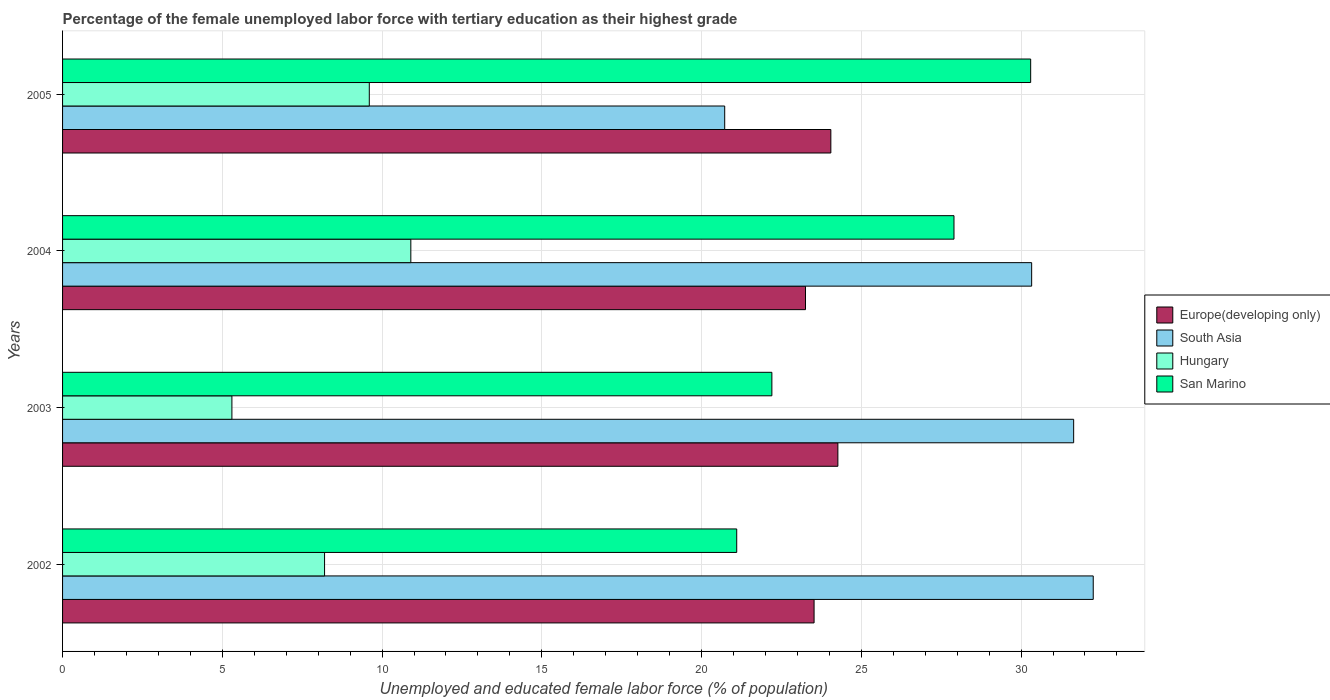How many groups of bars are there?
Offer a terse response. 4. How many bars are there on the 3rd tick from the top?
Provide a short and direct response. 4. What is the label of the 3rd group of bars from the top?
Offer a terse response. 2003. In how many cases, is the number of bars for a given year not equal to the number of legend labels?
Give a very brief answer. 0. What is the percentage of the unemployed female labor force with tertiary education in South Asia in 2005?
Provide a short and direct response. 20.72. Across all years, what is the maximum percentage of the unemployed female labor force with tertiary education in South Asia?
Make the answer very short. 32.26. Across all years, what is the minimum percentage of the unemployed female labor force with tertiary education in San Marino?
Provide a succinct answer. 21.1. In which year was the percentage of the unemployed female labor force with tertiary education in Hungary minimum?
Keep it short and to the point. 2003. What is the total percentage of the unemployed female labor force with tertiary education in Europe(developing only) in the graph?
Your response must be concise. 95.09. What is the difference between the percentage of the unemployed female labor force with tertiary education in San Marino in 2003 and that in 2005?
Provide a succinct answer. -8.1. What is the difference between the percentage of the unemployed female labor force with tertiary education in San Marino in 2005 and the percentage of the unemployed female labor force with tertiary education in Hungary in 2002?
Keep it short and to the point. 22.1. What is the average percentage of the unemployed female labor force with tertiary education in Europe(developing only) per year?
Your response must be concise. 23.77. In the year 2004, what is the difference between the percentage of the unemployed female labor force with tertiary education in San Marino and percentage of the unemployed female labor force with tertiary education in Hungary?
Ensure brevity in your answer.  17. What is the ratio of the percentage of the unemployed female labor force with tertiary education in Hungary in 2003 to that in 2004?
Make the answer very short. 0.49. What is the difference between the highest and the second highest percentage of the unemployed female labor force with tertiary education in South Asia?
Your answer should be compact. 0.61. What is the difference between the highest and the lowest percentage of the unemployed female labor force with tertiary education in South Asia?
Keep it short and to the point. 11.53. What does the 1st bar from the top in 2003 represents?
Provide a succinct answer. San Marino. What does the 3rd bar from the bottom in 2003 represents?
Keep it short and to the point. Hungary. Is it the case that in every year, the sum of the percentage of the unemployed female labor force with tertiary education in Europe(developing only) and percentage of the unemployed female labor force with tertiary education in San Marino is greater than the percentage of the unemployed female labor force with tertiary education in South Asia?
Give a very brief answer. Yes. What is the difference between two consecutive major ticks on the X-axis?
Provide a short and direct response. 5. Are the values on the major ticks of X-axis written in scientific E-notation?
Give a very brief answer. No. Does the graph contain any zero values?
Offer a very short reply. No. Does the graph contain grids?
Offer a terse response. Yes. Where does the legend appear in the graph?
Keep it short and to the point. Center right. What is the title of the graph?
Offer a terse response. Percentage of the female unemployed labor force with tertiary education as their highest grade. What is the label or title of the X-axis?
Your answer should be compact. Unemployed and educated female labor force (% of population). What is the label or title of the Y-axis?
Your answer should be compact. Years. What is the Unemployed and educated female labor force (% of population) in Europe(developing only) in 2002?
Make the answer very short. 23.52. What is the Unemployed and educated female labor force (% of population) of South Asia in 2002?
Offer a terse response. 32.26. What is the Unemployed and educated female labor force (% of population) in Hungary in 2002?
Your response must be concise. 8.2. What is the Unemployed and educated female labor force (% of population) in San Marino in 2002?
Ensure brevity in your answer.  21.1. What is the Unemployed and educated female labor force (% of population) in Europe(developing only) in 2003?
Offer a very short reply. 24.27. What is the Unemployed and educated female labor force (% of population) in South Asia in 2003?
Provide a short and direct response. 31.65. What is the Unemployed and educated female labor force (% of population) in Hungary in 2003?
Provide a succinct answer. 5.3. What is the Unemployed and educated female labor force (% of population) of San Marino in 2003?
Keep it short and to the point. 22.2. What is the Unemployed and educated female labor force (% of population) in Europe(developing only) in 2004?
Your answer should be very brief. 23.25. What is the Unemployed and educated female labor force (% of population) in South Asia in 2004?
Give a very brief answer. 30.33. What is the Unemployed and educated female labor force (% of population) of Hungary in 2004?
Make the answer very short. 10.9. What is the Unemployed and educated female labor force (% of population) in San Marino in 2004?
Make the answer very short. 27.9. What is the Unemployed and educated female labor force (% of population) in Europe(developing only) in 2005?
Keep it short and to the point. 24.05. What is the Unemployed and educated female labor force (% of population) of South Asia in 2005?
Give a very brief answer. 20.72. What is the Unemployed and educated female labor force (% of population) of Hungary in 2005?
Your response must be concise. 9.6. What is the Unemployed and educated female labor force (% of population) in San Marino in 2005?
Provide a short and direct response. 30.3. Across all years, what is the maximum Unemployed and educated female labor force (% of population) of Europe(developing only)?
Your response must be concise. 24.27. Across all years, what is the maximum Unemployed and educated female labor force (% of population) in South Asia?
Provide a succinct answer. 32.26. Across all years, what is the maximum Unemployed and educated female labor force (% of population) of Hungary?
Your response must be concise. 10.9. Across all years, what is the maximum Unemployed and educated female labor force (% of population) in San Marino?
Keep it short and to the point. 30.3. Across all years, what is the minimum Unemployed and educated female labor force (% of population) in Europe(developing only)?
Keep it short and to the point. 23.25. Across all years, what is the minimum Unemployed and educated female labor force (% of population) of South Asia?
Your answer should be very brief. 20.72. Across all years, what is the minimum Unemployed and educated female labor force (% of population) in Hungary?
Offer a terse response. 5.3. Across all years, what is the minimum Unemployed and educated female labor force (% of population) of San Marino?
Provide a succinct answer. 21.1. What is the total Unemployed and educated female labor force (% of population) of Europe(developing only) in the graph?
Keep it short and to the point. 95.09. What is the total Unemployed and educated female labor force (% of population) of South Asia in the graph?
Give a very brief answer. 114.96. What is the total Unemployed and educated female labor force (% of population) of San Marino in the graph?
Your response must be concise. 101.5. What is the difference between the Unemployed and educated female labor force (% of population) of Europe(developing only) in 2002 and that in 2003?
Offer a very short reply. -0.74. What is the difference between the Unemployed and educated female labor force (% of population) of South Asia in 2002 and that in 2003?
Ensure brevity in your answer.  0.61. What is the difference between the Unemployed and educated female labor force (% of population) of San Marino in 2002 and that in 2003?
Offer a very short reply. -1.1. What is the difference between the Unemployed and educated female labor force (% of population) of Europe(developing only) in 2002 and that in 2004?
Your answer should be compact. 0.27. What is the difference between the Unemployed and educated female labor force (% of population) of South Asia in 2002 and that in 2004?
Offer a terse response. 1.93. What is the difference between the Unemployed and educated female labor force (% of population) in Hungary in 2002 and that in 2004?
Keep it short and to the point. -2.7. What is the difference between the Unemployed and educated female labor force (% of population) in Europe(developing only) in 2002 and that in 2005?
Provide a succinct answer. -0.52. What is the difference between the Unemployed and educated female labor force (% of population) of South Asia in 2002 and that in 2005?
Offer a very short reply. 11.53. What is the difference between the Unemployed and educated female labor force (% of population) in Hungary in 2002 and that in 2005?
Offer a terse response. -1.4. What is the difference between the Unemployed and educated female labor force (% of population) of San Marino in 2002 and that in 2005?
Ensure brevity in your answer.  -9.2. What is the difference between the Unemployed and educated female labor force (% of population) in Europe(developing only) in 2003 and that in 2004?
Make the answer very short. 1.01. What is the difference between the Unemployed and educated female labor force (% of population) in South Asia in 2003 and that in 2004?
Your answer should be very brief. 1.31. What is the difference between the Unemployed and educated female labor force (% of population) of Europe(developing only) in 2003 and that in 2005?
Give a very brief answer. 0.22. What is the difference between the Unemployed and educated female labor force (% of population) in South Asia in 2003 and that in 2005?
Your answer should be very brief. 10.92. What is the difference between the Unemployed and educated female labor force (% of population) in Europe(developing only) in 2004 and that in 2005?
Give a very brief answer. -0.79. What is the difference between the Unemployed and educated female labor force (% of population) of South Asia in 2004 and that in 2005?
Make the answer very short. 9.61. What is the difference between the Unemployed and educated female labor force (% of population) of Hungary in 2004 and that in 2005?
Your answer should be very brief. 1.3. What is the difference between the Unemployed and educated female labor force (% of population) of Europe(developing only) in 2002 and the Unemployed and educated female labor force (% of population) of South Asia in 2003?
Ensure brevity in your answer.  -8.12. What is the difference between the Unemployed and educated female labor force (% of population) of Europe(developing only) in 2002 and the Unemployed and educated female labor force (% of population) of Hungary in 2003?
Keep it short and to the point. 18.22. What is the difference between the Unemployed and educated female labor force (% of population) in Europe(developing only) in 2002 and the Unemployed and educated female labor force (% of population) in San Marino in 2003?
Keep it short and to the point. 1.32. What is the difference between the Unemployed and educated female labor force (% of population) in South Asia in 2002 and the Unemployed and educated female labor force (% of population) in Hungary in 2003?
Offer a terse response. 26.96. What is the difference between the Unemployed and educated female labor force (% of population) of South Asia in 2002 and the Unemployed and educated female labor force (% of population) of San Marino in 2003?
Ensure brevity in your answer.  10.06. What is the difference between the Unemployed and educated female labor force (% of population) of Hungary in 2002 and the Unemployed and educated female labor force (% of population) of San Marino in 2003?
Provide a succinct answer. -14. What is the difference between the Unemployed and educated female labor force (% of population) in Europe(developing only) in 2002 and the Unemployed and educated female labor force (% of population) in South Asia in 2004?
Give a very brief answer. -6.81. What is the difference between the Unemployed and educated female labor force (% of population) in Europe(developing only) in 2002 and the Unemployed and educated female labor force (% of population) in Hungary in 2004?
Your answer should be compact. 12.62. What is the difference between the Unemployed and educated female labor force (% of population) of Europe(developing only) in 2002 and the Unemployed and educated female labor force (% of population) of San Marino in 2004?
Your answer should be compact. -4.38. What is the difference between the Unemployed and educated female labor force (% of population) of South Asia in 2002 and the Unemployed and educated female labor force (% of population) of Hungary in 2004?
Provide a succinct answer. 21.36. What is the difference between the Unemployed and educated female labor force (% of population) of South Asia in 2002 and the Unemployed and educated female labor force (% of population) of San Marino in 2004?
Your answer should be very brief. 4.36. What is the difference between the Unemployed and educated female labor force (% of population) of Hungary in 2002 and the Unemployed and educated female labor force (% of population) of San Marino in 2004?
Provide a succinct answer. -19.7. What is the difference between the Unemployed and educated female labor force (% of population) in Europe(developing only) in 2002 and the Unemployed and educated female labor force (% of population) in South Asia in 2005?
Your response must be concise. 2.8. What is the difference between the Unemployed and educated female labor force (% of population) of Europe(developing only) in 2002 and the Unemployed and educated female labor force (% of population) of Hungary in 2005?
Make the answer very short. 13.92. What is the difference between the Unemployed and educated female labor force (% of population) in Europe(developing only) in 2002 and the Unemployed and educated female labor force (% of population) in San Marino in 2005?
Offer a very short reply. -6.78. What is the difference between the Unemployed and educated female labor force (% of population) in South Asia in 2002 and the Unemployed and educated female labor force (% of population) in Hungary in 2005?
Offer a very short reply. 22.66. What is the difference between the Unemployed and educated female labor force (% of population) in South Asia in 2002 and the Unemployed and educated female labor force (% of population) in San Marino in 2005?
Provide a short and direct response. 1.96. What is the difference between the Unemployed and educated female labor force (% of population) of Hungary in 2002 and the Unemployed and educated female labor force (% of population) of San Marino in 2005?
Offer a terse response. -22.1. What is the difference between the Unemployed and educated female labor force (% of population) of Europe(developing only) in 2003 and the Unemployed and educated female labor force (% of population) of South Asia in 2004?
Your answer should be very brief. -6.06. What is the difference between the Unemployed and educated female labor force (% of population) in Europe(developing only) in 2003 and the Unemployed and educated female labor force (% of population) in Hungary in 2004?
Keep it short and to the point. 13.37. What is the difference between the Unemployed and educated female labor force (% of population) of Europe(developing only) in 2003 and the Unemployed and educated female labor force (% of population) of San Marino in 2004?
Your answer should be very brief. -3.63. What is the difference between the Unemployed and educated female labor force (% of population) in South Asia in 2003 and the Unemployed and educated female labor force (% of population) in Hungary in 2004?
Ensure brevity in your answer.  20.75. What is the difference between the Unemployed and educated female labor force (% of population) of South Asia in 2003 and the Unemployed and educated female labor force (% of population) of San Marino in 2004?
Ensure brevity in your answer.  3.75. What is the difference between the Unemployed and educated female labor force (% of population) in Hungary in 2003 and the Unemployed and educated female labor force (% of population) in San Marino in 2004?
Provide a succinct answer. -22.6. What is the difference between the Unemployed and educated female labor force (% of population) of Europe(developing only) in 2003 and the Unemployed and educated female labor force (% of population) of South Asia in 2005?
Ensure brevity in your answer.  3.54. What is the difference between the Unemployed and educated female labor force (% of population) of Europe(developing only) in 2003 and the Unemployed and educated female labor force (% of population) of Hungary in 2005?
Ensure brevity in your answer.  14.67. What is the difference between the Unemployed and educated female labor force (% of population) of Europe(developing only) in 2003 and the Unemployed and educated female labor force (% of population) of San Marino in 2005?
Offer a very short reply. -6.03. What is the difference between the Unemployed and educated female labor force (% of population) of South Asia in 2003 and the Unemployed and educated female labor force (% of population) of Hungary in 2005?
Offer a very short reply. 22.05. What is the difference between the Unemployed and educated female labor force (% of population) of South Asia in 2003 and the Unemployed and educated female labor force (% of population) of San Marino in 2005?
Ensure brevity in your answer.  1.35. What is the difference between the Unemployed and educated female labor force (% of population) of Hungary in 2003 and the Unemployed and educated female labor force (% of population) of San Marino in 2005?
Your answer should be very brief. -25. What is the difference between the Unemployed and educated female labor force (% of population) of Europe(developing only) in 2004 and the Unemployed and educated female labor force (% of population) of South Asia in 2005?
Your answer should be compact. 2.53. What is the difference between the Unemployed and educated female labor force (% of population) in Europe(developing only) in 2004 and the Unemployed and educated female labor force (% of population) in Hungary in 2005?
Ensure brevity in your answer.  13.65. What is the difference between the Unemployed and educated female labor force (% of population) of Europe(developing only) in 2004 and the Unemployed and educated female labor force (% of population) of San Marino in 2005?
Ensure brevity in your answer.  -7.05. What is the difference between the Unemployed and educated female labor force (% of population) of South Asia in 2004 and the Unemployed and educated female labor force (% of population) of Hungary in 2005?
Keep it short and to the point. 20.73. What is the difference between the Unemployed and educated female labor force (% of population) in South Asia in 2004 and the Unemployed and educated female labor force (% of population) in San Marino in 2005?
Your response must be concise. 0.03. What is the difference between the Unemployed and educated female labor force (% of population) of Hungary in 2004 and the Unemployed and educated female labor force (% of population) of San Marino in 2005?
Keep it short and to the point. -19.4. What is the average Unemployed and educated female labor force (% of population) of Europe(developing only) per year?
Ensure brevity in your answer.  23.77. What is the average Unemployed and educated female labor force (% of population) of South Asia per year?
Ensure brevity in your answer.  28.74. What is the average Unemployed and educated female labor force (% of population) in Hungary per year?
Offer a terse response. 8.5. What is the average Unemployed and educated female labor force (% of population) in San Marino per year?
Provide a succinct answer. 25.38. In the year 2002, what is the difference between the Unemployed and educated female labor force (% of population) of Europe(developing only) and Unemployed and educated female labor force (% of population) of South Asia?
Your response must be concise. -8.74. In the year 2002, what is the difference between the Unemployed and educated female labor force (% of population) of Europe(developing only) and Unemployed and educated female labor force (% of population) of Hungary?
Your answer should be compact. 15.32. In the year 2002, what is the difference between the Unemployed and educated female labor force (% of population) in Europe(developing only) and Unemployed and educated female labor force (% of population) in San Marino?
Your answer should be compact. 2.42. In the year 2002, what is the difference between the Unemployed and educated female labor force (% of population) in South Asia and Unemployed and educated female labor force (% of population) in Hungary?
Your answer should be compact. 24.06. In the year 2002, what is the difference between the Unemployed and educated female labor force (% of population) in South Asia and Unemployed and educated female labor force (% of population) in San Marino?
Provide a short and direct response. 11.16. In the year 2003, what is the difference between the Unemployed and educated female labor force (% of population) in Europe(developing only) and Unemployed and educated female labor force (% of population) in South Asia?
Make the answer very short. -7.38. In the year 2003, what is the difference between the Unemployed and educated female labor force (% of population) in Europe(developing only) and Unemployed and educated female labor force (% of population) in Hungary?
Keep it short and to the point. 18.97. In the year 2003, what is the difference between the Unemployed and educated female labor force (% of population) of Europe(developing only) and Unemployed and educated female labor force (% of population) of San Marino?
Give a very brief answer. 2.07. In the year 2003, what is the difference between the Unemployed and educated female labor force (% of population) in South Asia and Unemployed and educated female labor force (% of population) in Hungary?
Offer a terse response. 26.35. In the year 2003, what is the difference between the Unemployed and educated female labor force (% of population) of South Asia and Unemployed and educated female labor force (% of population) of San Marino?
Your answer should be compact. 9.45. In the year 2003, what is the difference between the Unemployed and educated female labor force (% of population) in Hungary and Unemployed and educated female labor force (% of population) in San Marino?
Keep it short and to the point. -16.9. In the year 2004, what is the difference between the Unemployed and educated female labor force (% of population) of Europe(developing only) and Unemployed and educated female labor force (% of population) of South Asia?
Your answer should be compact. -7.08. In the year 2004, what is the difference between the Unemployed and educated female labor force (% of population) in Europe(developing only) and Unemployed and educated female labor force (% of population) in Hungary?
Give a very brief answer. 12.35. In the year 2004, what is the difference between the Unemployed and educated female labor force (% of population) in Europe(developing only) and Unemployed and educated female labor force (% of population) in San Marino?
Your answer should be very brief. -4.65. In the year 2004, what is the difference between the Unemployed and educated female labor force (% of population) of South Asia and Unemployed and educated female labor force (% of population) of Hungary?
Offer a terse response. 19.43. In the year 2004, what is the difference between the Unemployed and educated female labor force (% of population) of South Asia and Unemployed and educated female labor force (% of population) of San Marino?
Ensure brevity in your answer.  2.43. In the year 2004, what is the difference between the Unemployed and educated female labor force (% of population) in Hungary and Unemployed and educated female labor force (% of population) in San Marino?
Keep it short and to the point. -17. In the year 2005, what is the difference between the Unemployed and educated female labor force (% of population) in Europe(developing only) and Unemployed and educated female labor force (% of population) in South Asia?
Ensure brevity in your answer.  3.32. In the year 2005, what is the difference between the Unemployed and educated female labor force (% of population) of Europe(developing only) and Unemployed and educated female labor force (% of population) of Hungary?
Your response must be concise. 14.45. In the year 2005, what is the difference between the Unemployed and educated female labor force (% of population) of Europe(developing only) and Unemployed and educated female labor force (% of population) of San Marino?
Give a very brief answer. -6.25. In the year 2005, what is the difference between the Unemployed and educated female labor force (% of population) of South Asia and Unemployed and educated female labor force (% of population) of Hungary?
Offer a very short reply. 11.12. In the year 2005, what is the difference between the Unemployed and educated female labor force (% of population) in South Asia and Unemployed and educated female labor force (% of population) in San Marino?
Your answer should be compact. -9.58. In the year 2005, what is the difference between the Unemployed and educated female labor force (% of population) in Hungary and Unemployed and educated female labor force (% of population) in San Marino?
Offer a very short reply. -20.7. What is the ratio of the Unemployed and educated female labor force (% of population) of Europe(developing only) in 2002 to that in 2003?
Your answer should be compact. 0.97. What is the ratio of the Unemployed and educated female labor force (% of population) of South Asia in 2002 to that in 2003?
Make the answer very short. 1.02. What is the ratio of the Unemployed and educated female labor force (% of population) in Hungary in 2002 to that in 2003?
Keep it short and to the point. 1.55. What is the ratio of the Unemployed and educated female labor force (% of population) of San Marino in 2002 to that in 2003?
Offer a very short reply. 0.95. What is the ratio of the Unemployed and educated female labor force (% of population) in Europe(developing only) in 2002 to that in 2004?
Provide a succinct answer. 1.01. What is the ratio of the Unemployed and educated female labor force (% of population) in South Asia in 2002 to that in 2004?
Give a very brief answer. 1.06. What is the ratio of the Unemployed and educated female labor force (% of population) in Hungary in 2002 to that in 2004?
Provide a short and direct response. 0.75. What is the ratio of the Unemployed and educated female labor force (% of population) of San Marino in 2002 to that in 2004?
Ensure brevity in your answer.  0.76. What is the ratio of the Unemployed and educated female labor force (% of population) of Europe(developing only) in 2002 to that in 2005?
Provide a succinct answer. 0.98. What is the ratio of the Unemployed and educated female labor force (% of population) in South Asia in 2002 to that in 2005?
Your answer should be very brief. 1.56. What is the ratio of the Unemployed and educated female labor force (% of population) in Hungary in 2002 to that in 2005?
Your answer should be compact. 0.85. What is the ratio of the Unemployed and educated female labor force (% of population) in San Marino in 2002 to that in 2005?
Keep it short and to the point. 0.7. What is the ratio of the Unemployed and educated female labor force (% of population) in Europe(developing only) in 2003 to that in 2004?
Offer a terse response. 1.04. What is the ratio of the Unemployed and educated female labor force (% of population) in South Asia in 2003 to that in 2004?
Make the answer very short. 1.04. What is the ratio of the Unemployed and educated female labor force (% of population) of Hungary in 2003 to that in 2004?
Your response must be concise. 0.49. What is the ratio of the Unemployed and educated female labor force (% of population) of San Marino in 2003 to that in 2004?
Provide a succinct answer. 0.8. What is the ratio of the Unemployed and educated female labor force (% of population) in Europe(developing only) in 2003 to that in 2005?
Offer a terse response. 1.01. What is the ratio of the Unemployed and educated female labor force (% of population) of South Asia in 2003 to that in 2005?
Keep it short and to the point. 1.53. What is the ratio of the Unemployed and educated female labor force (% of population) in Hungary in 2003 to that in 2005?
Your response must be concise. 0.55. What is the ratio of the Unemployed and educated female labor force (% of population) in San Marino in 2003 to that in 2005?
Provide a succinct answer. 0.73. What is the ratio of the Unemployed and educated female labor force (% of population) in Europe(developing only) in 2004 to that in 2005?
Make the answer very short. 0.97. What is the ratio of the Unemployed and educated female labor force (% of population) in South Asia in 2004 to that in 2005?
Your answer should be very brief. 1.46. What is the ratio of the Unemployed and educated female labor force (% of population) of Hungary in 2004 to that in 2005?
Your answer should be very brief. 1.14. What is the ratio of the Unemployed and educated female labor force (% of population) of San Marino in 2004 to that in 2005?
Your answer should be very brief. 0.92. What is the difference between the highest and the second highest Unemployed and educated female labor force (% of population) in Europe(developing only)?
Provide a succinct answer. 0.22. What is the difference between the highest and the second highest Unemployed and educated female labor force (% of population) of South Asia?
Provide a short and direct response. 0.61. What is the difference between the highest and the second highest Unemployed and educated female labor force (% of population) in Hungary?
Give a very brief answer. 1.3. What is the difference between the highest and the lowest Unemployed and educated female labor force (% of population) of Europe(developing only)?
Provide a short and direct response. 1.01. What is the difference between the highest and the lowest Unemployed and educated female labor force (% of population) in South Asia?
Give a very brief answer. 11.53. What is the difference between the highest and the lowest Unemployed and educated female labor force (% of population) in San Marino?
Offer a terse response. 9.2. 